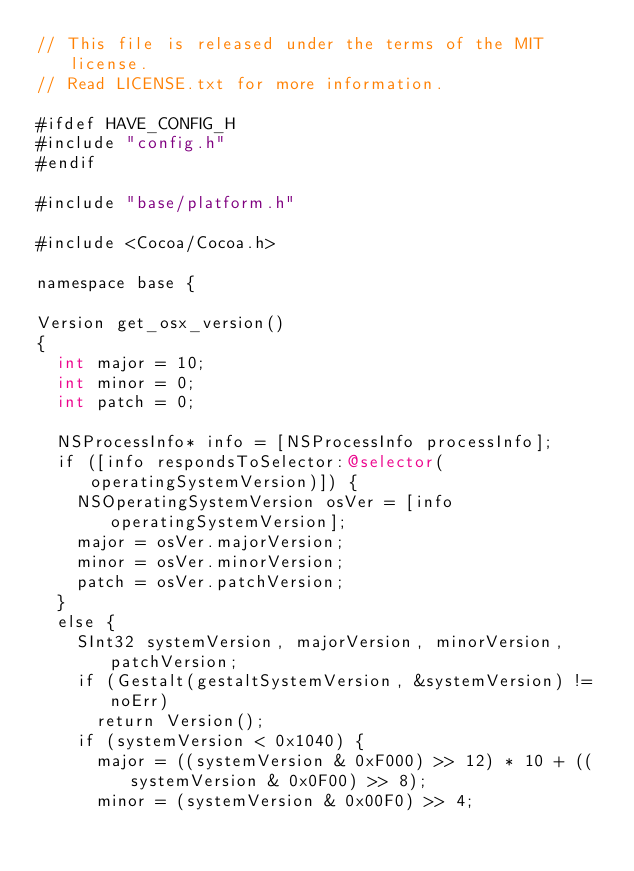<code> <loc_0><loc_0><loc_500><loc_500><_ObjectiveC_>// This file is released under the terms of the MIT license.
// Read LICENSE.txt for more information.

#ifdef HAVE_CONFIG_H
#include "config.h"
#endif

#include "base/platform.h"

#include <Cocoa/Cocoa.h>

namespace base {

Version get_osx_version()
{
  int major = 10;
  int minor = 0;
  int patch = 0;

  NSProcessInfo* info = [NSProcessInfo processInfo];
  if ([info respondsToSelector:@selector(operatingSystemVersion)]) {
    NSOperatingSystemVersion osVer = [info operatingSystemVersion];
    major = osVer.majorVersion;
    minor = osVer.minorVersion;
    patch = osVer.patchVersion;
  }
  else {
    SInt32 systemVersion, majorVersion, minorVersion, patchVersion;
    if (Gestalt(gestaltSystemVersion, &systemVersion) != noErr)
      return Version();
    if (systemVersion < 0x1040) {
      major = ((systemVersion & 0xF000) >> 12) * 10 + ((systemVersion & 0x0F00) >> 8);
      minor = (systemVersion & 0x00F0) >> 4;</code> 